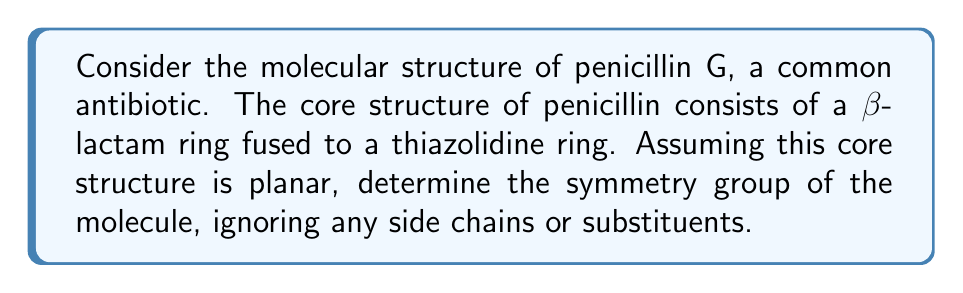What is the answer to this math problem? To determine the symmetry group of the penicillin core structure, we need to analyze its symmetry operations:

1. Identity (E): The molecule always has this symmetry operation.

2. Rotations: The molecule does not have any rotational symmetry due to its irregular shape.

3. Reflection: There is one plane of symmetry that bisects the molecule through the β-lactam and thiazolidine rings.

4. Inversion: The molecule does not have an inversion center.

Given these symmetry operations, we can conclude that the molecule belongs to the $C_s$ point group. The $C_s$ group consists of two symmetry operations:

1. E: The identity operation
2. $\sigma$: A reflection operation

The character table for the $C_s$ group is:

$$
\begin{array}{c|cc}
C_s & E & \sigma \\
\hline
A' & 1 & 1 \\
A'' & 1 & -1
\end{array}
$$

Where $A'$ represents symmetric operations with respect to the reflection plane, and $A''$ represents antisymmetric operations.

The order of the group (number of elements) is 2.

In group theory notation, we can express this group as:

$$ C_s = \{E, \sigma\} $$

This group is isomorphic to the cyclic group $Z_2$, which is the simplest non-trivial group.
Answer: The symmetry group of the penicillin core structure (ignoring side chains) is $C_s$, which consists of the identity operation (E) and one reflection operation ($\sigma$). 